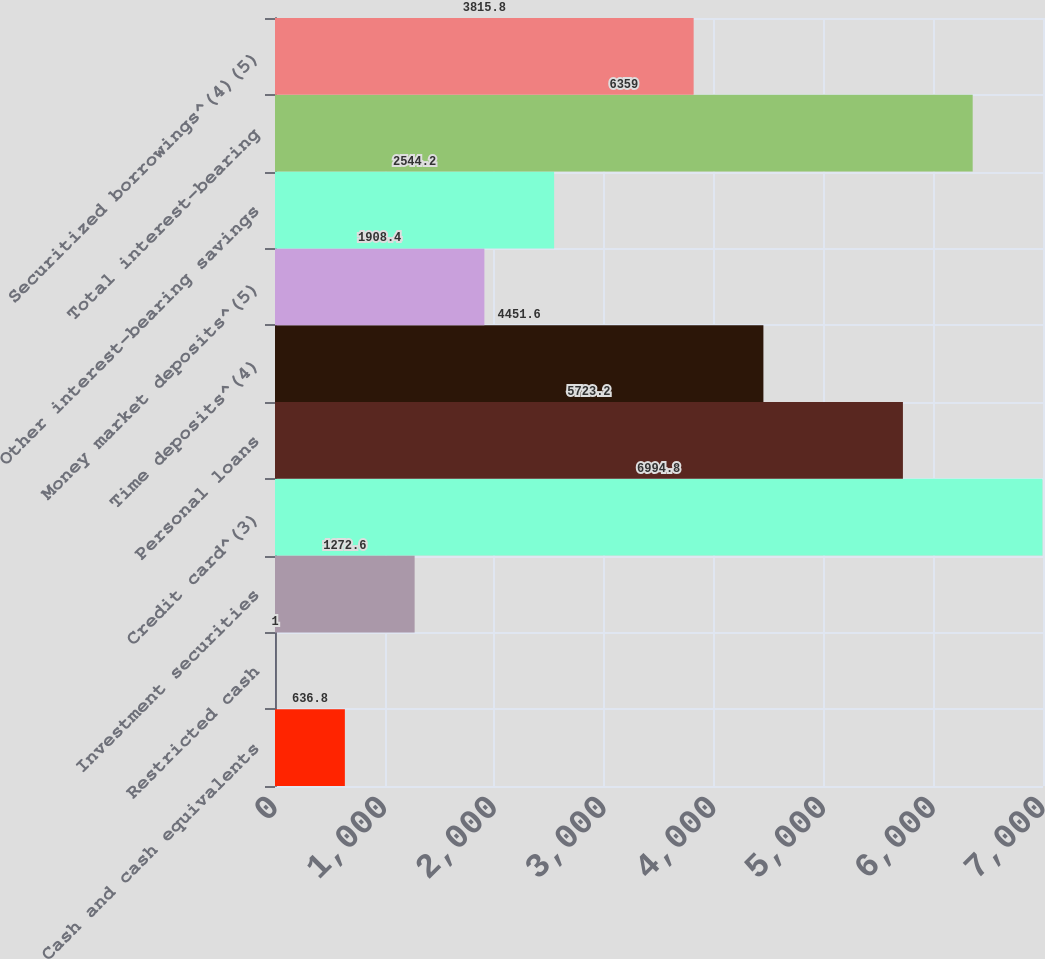<chart> <loc_0><loc_0><loc_500><loc_500><bar_chart><fcel>Cash and cash equivalents<fcel>Restricted cash<fcel>Investment securities<fcel>Credit card^(3)<fcel>Personal loans<fcel>Time deposits^(4)<fcel>Money market deposits^(5)<fcel>Other interest-bearing savings<fcel>Total interest-bearing<fcel>Securitized borrowings^(4)(5)<nl><fcel>636.8<fcel>1<fcel>1272.6<fcel>6994.8<fcel>5723.2<fcel>4451.6<fcel>1908.4<fcel>2544.2<fcel>6359<fcel>3815.8<nl></chart> 